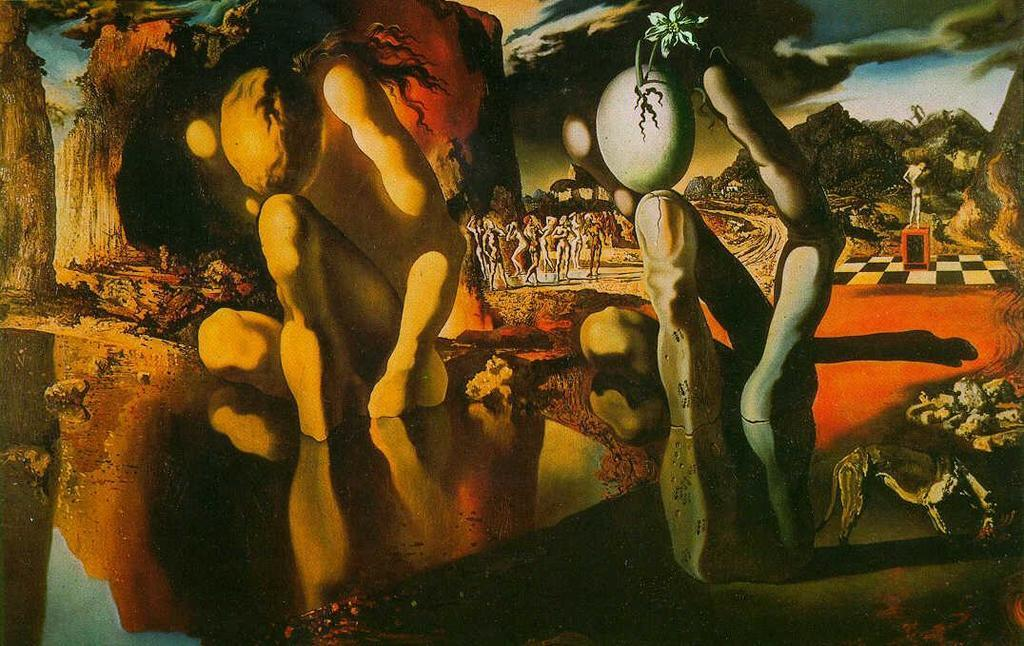What type of natural formations can be seen in the image? There are caves and mountains in the image. Can you describe the landscape in the image? The landscape features caves and mountains. What other objects are present in the image? There are other objects in the image, but their specific details are not mentioned in the provided facts. What type of thrill can be experienced by using a wrench in the image? There is no wrench present in the image, and therefore no such activity or experience can be observed. 